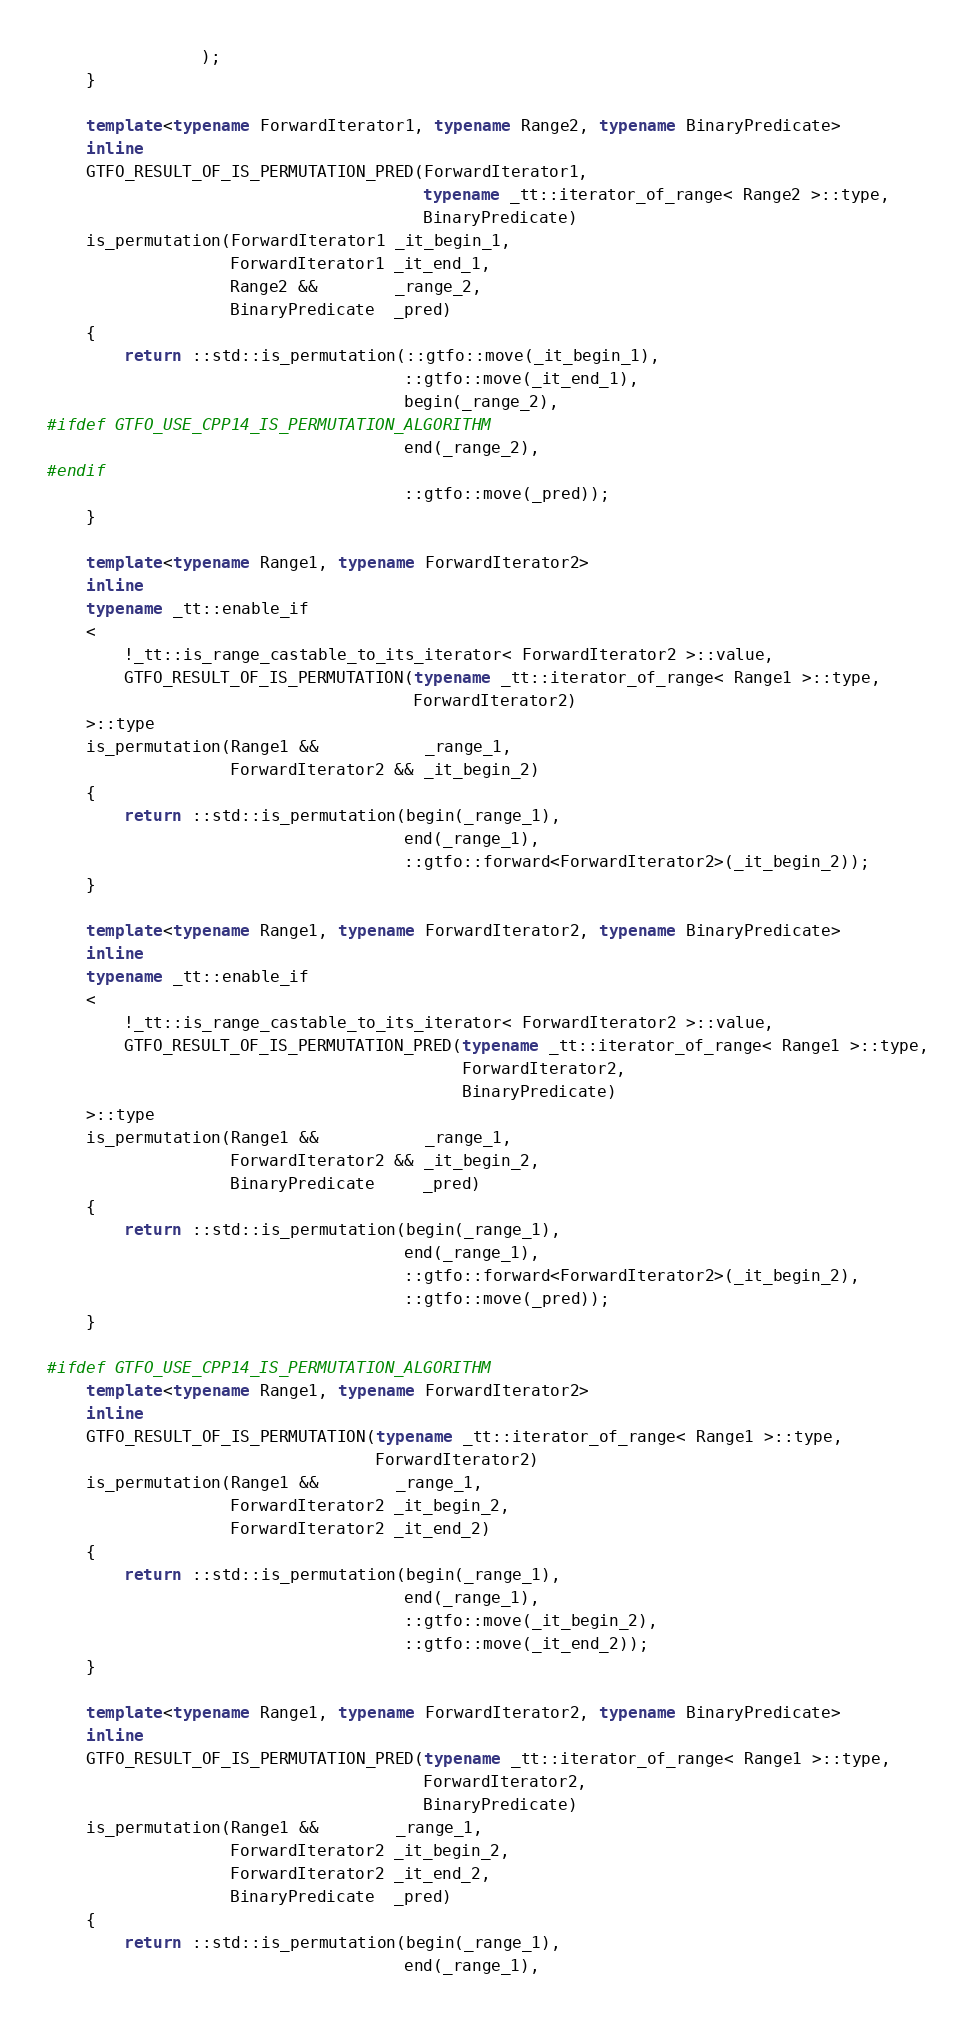Convert code to text. <code><loc_0><loc_0><loc_500><loc_500><_C++_>                );
    }

    template<typename ForwardIterator1, typename Range2, typename BinaryPredicate>
    inline
    GTFO_RESULT_OF_IS_PERMUTATION_PRED(ForwardIterator1,
                                       typename _tt::iterator_of_range< Range2 >::type,
                                       BinaryPredicate)
    is_permutation(ForwardIterator1 _it_begin_1,
                   ForwardIterator1 _it_end_1,
                   Range2 &&        _range_2,
                   BinaryPredicate  _pred)
    {
        return ::std::is_permutation(::gtfo::move(_it_begin_1),
                                     ::gtfo::move(_it_end_1),
                                     begin(_range_2),
#ifdef GTFO_USE_CPP14_IS_PERMUTATION_ALGORITHM
                                     end(_range_2),
#endif
                                     ::gtfo::move(_pred));
    }

    template<typename Range1, typename ForwardIterator2>
    inline
    typename _tt::enable_if
    <
        !_tt::is_range_castable_to_its_iterator< ForwardIterator2 >::value,
        GTFO_RESULT_OF_IS_PERMUTATION(typename _tt::iterator_of_range< Range1 >::type,
                                      ForwardIterator2)
    >::type
    is_permutation(Range1 &&           _range_1,
                   ForwardIterator2 && _it_begin_2)
    {
        return ::std::is_permutation(begin(_range_1),
                                     end(_range_1),
                                     ::gtfo::forward<ForwardIterator2>(_it_begin_2));
    }

    template<typename Range1, typename ForwardIterator2, typename BinaryPredicate>
    inline
    typename _tt::enable_if
    <
        !_tt::is_range_castable_to_its_iterator< ForwardIterator2 >::value,
        GTFO_RESULT_OF_IS_PERMUTATION_PRED(typename _tt::iterator_of_range< Range1 >::type,
                                           ForwardIterator2,
                                           BinaryPredicate)
    >::type
    is_permutation(Range1 &&           _range_1,
                   ForwardIterator2 && _it_begin_2,
                   BinaryPredicate     _pred)
    {
        return ::std::is_permutation(begin(_range_1),
                                     end(_range_1),
                                     ::gtfo::forward<ForwardIterator2>(_it_begin_2),
                                     ::gtfo::move(_pred));
    }

#ifdef GTFO_USE_CPP14_IS_PERMUTATION_ALGORITHM
    template<typename Range1, typename ForwardIterator2>
    inline
    GTFO_RESULT_OF_IS_PERMUTATION(typename _tt::iterator_of_range< Range1 >::type,
                                  ForwardIterator2)
    is_permutation(Range1 &&        _range_1,
                   ForwardIterator2 _it_begin_2,
                   ForwardIterator2 _it_end_2)
    {
        return ::std::is_permutation(begin(_range_1),
                                     end(_range_1),
                                     ::gtfo::move(_it_begin_2),
                                     ::gtfo::move(_it_end_2));
    }

    template<typename Range1, typename ForwardIterator2, typename BinaryPredicate>
    inline
    GTFO_RESULT_OF_IS_PERMUTATION_PRED(typename _tt::iterator_of_range< Range1 >::type,
                                       ForwardIterator2,
                                       BinaryPredicate)
    is_permutation(Range1 &&        _range_1,
                   ForwardIterator2 _it_begin_2,
                   ForwardIterator2 _it_end_2,
                   BinaryPredicate  _pred)
    {
        return ::std::is_permutation(begin(_range_1),
                                     end(_range_1),</code> 